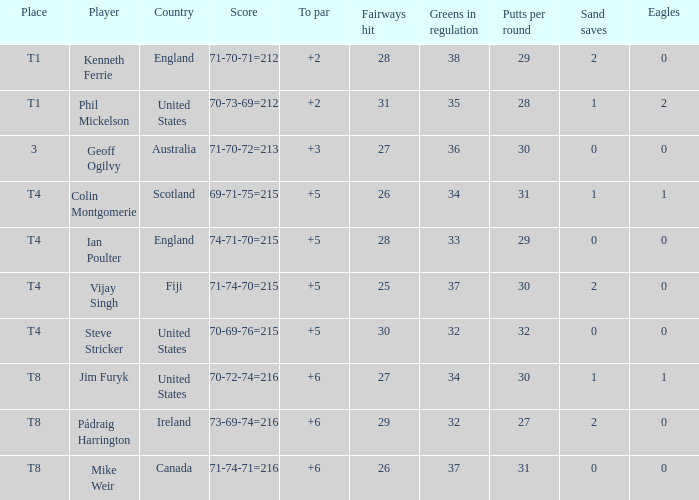What player was place of t1 in To Par and had a score of 70-73-69=212? 2.0. 